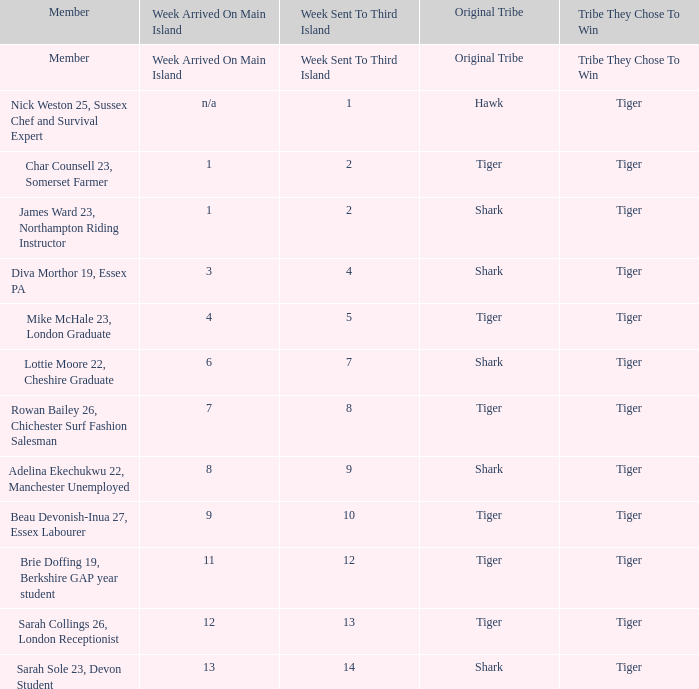What week was the member who arrived on the main island in week 6 sent to the third island? 7.0. Can you parse all the data within this table? {'header': ['Member', 'Week Arrived On Main Island', 'Week Sent To Third Island', 'Original Tribe', 'Tribe They Chose To Win'], 'rows': [['Member', 'Week Arrived On Main Island', 'Week Sent To Third Island', 'Original Tribe', 'Tribe They Chose To Win'], ['Nick Weston 25, Sussex Chef and Survival Expert', 'n/a', '1', 'Hawk', 'Tiger'], ['Char Counsell 23, Somerset Farmer', '1', '2', 'Tiger', 'Tiger'], ['James Ward 23, Northampton Riding Instructor', '1', '2', 'Shark', 'Tiger'], ['Diva Morthor 19, Essex PA', '3', '4', 'Shark', 'Tiger'], ['Mike McHale 23, London Graduate', '4', '5', 'Tiger', 'Tiger'], ['Lottie Moore 22, Cheshire Graduate', '6', '7', 'Shark', 'Tiger'], ['Rowan Bailey 26, Chichester Surf Fashion Salesman', '7', '8', 'Tiger', 'Tiger'], ['Adelina Ekechukwu 22, Manchester Unemployed', '8', '9', 'Shark', 'Tiger'], ['Beau Devonish-Inua 27, Essex Labourer', '9', '10', 'Tiger', 'Tiger'], ['Brie Doffing 19, Berkshire GAP year student', '11', '12', 'Tiger', 'Tiger'], ['Sarah Collings 26, London Receptionist', '12', '13', 'Tiger', 'Tiger'], ['Sarah Sole 23, Devon Student', '13', '14', 'Shark', 'Tiger']]} 